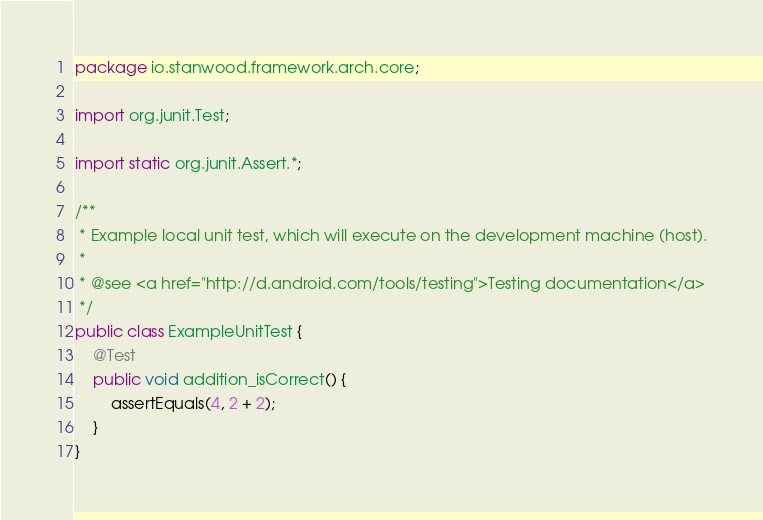Convert code to text. <code><loc_0><loc_0><loc_500><loc_500><_Java_>package io.stanwood.framework.arch.core;

import org.junit.Test;

import static org.junit.Assert.*;

/**
 * Example local unit test, which will execute on the development machine (host).
 *
 * @see <a href="http://d.android.com/tools/testing">Testing documentation</a>
 */
public class ExampleUnitTest {
    @Test
    public void addition_isCorrect() {
        assertEquals(4, 2 + 2);
    }
}</code> 